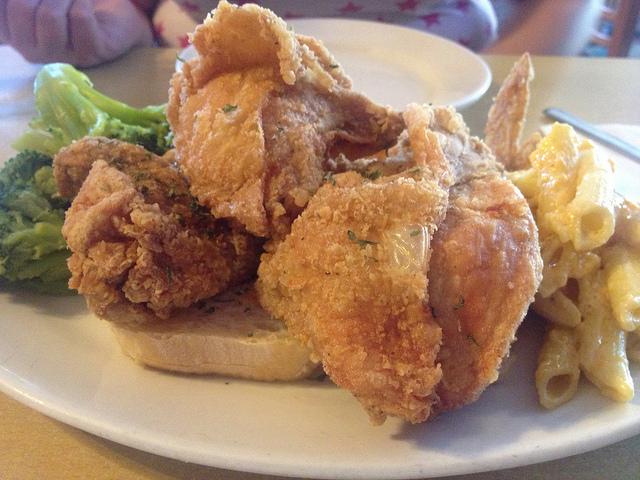What do you call the pasta side dish?
Quick response, please. Penne. What vegetable is served with the chicken?
Quick response, please. Broccoli. Who made this chicken?
Quick response, please. Mom. 